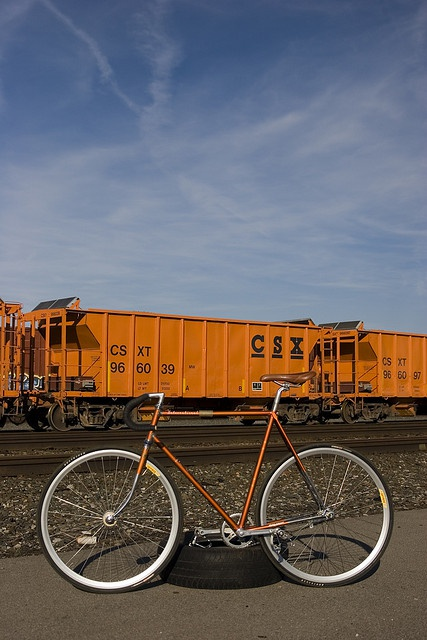Describe the objects in this image and their specific colors. I can see bicycle in gray and black tones and train in gray, red, black, and maroon tones in this image. 